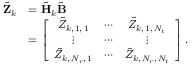<formula> <loc_0><loc_0><loc_500><loc_500>\begin{array} { r l } { \tilde { Z } _ { k } } & { = \tilde { H } _ { k } \tilde { B } } \\ & { = \left [ \begin{array} { c c c } { \tilde { Z } _ { k , \, 1 , \, 1 } } & { \cdots } & { \tilde { Z } _ { k , \, 1 , \, N _ { t } } } \\ { \vdots } & { \cdots } & { \vdots } \\ { \tilde { Z } _ { k , \, N _ { r } , \, 1 } } & { \cdots } & { \tilde { Z } _ { k , \, N _ { r } , \, N _ { t } } } \end{array} \right ] . } \end{array}</formula> 